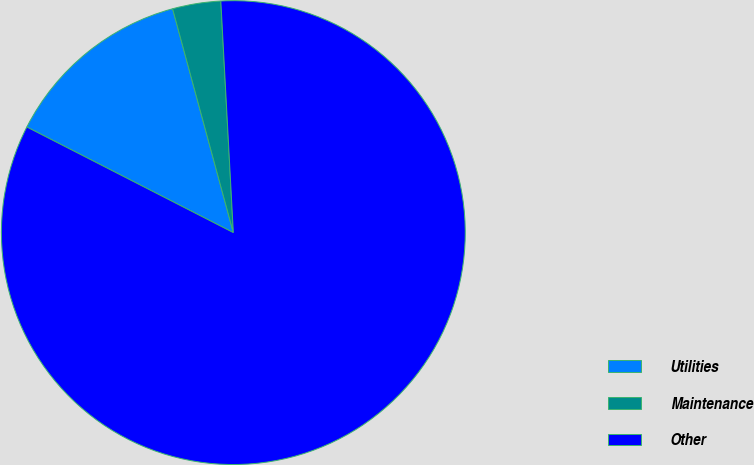Convert chart to OTSL. <chart><loc_0><loc_0><loc_500><loc_500><pie_chart><fcel>Utilities<fcel>Maintenance<fcel>Other<nl><fcel>13.26%<fcel>3.36%<fcel>83.39%<nl></chart> 